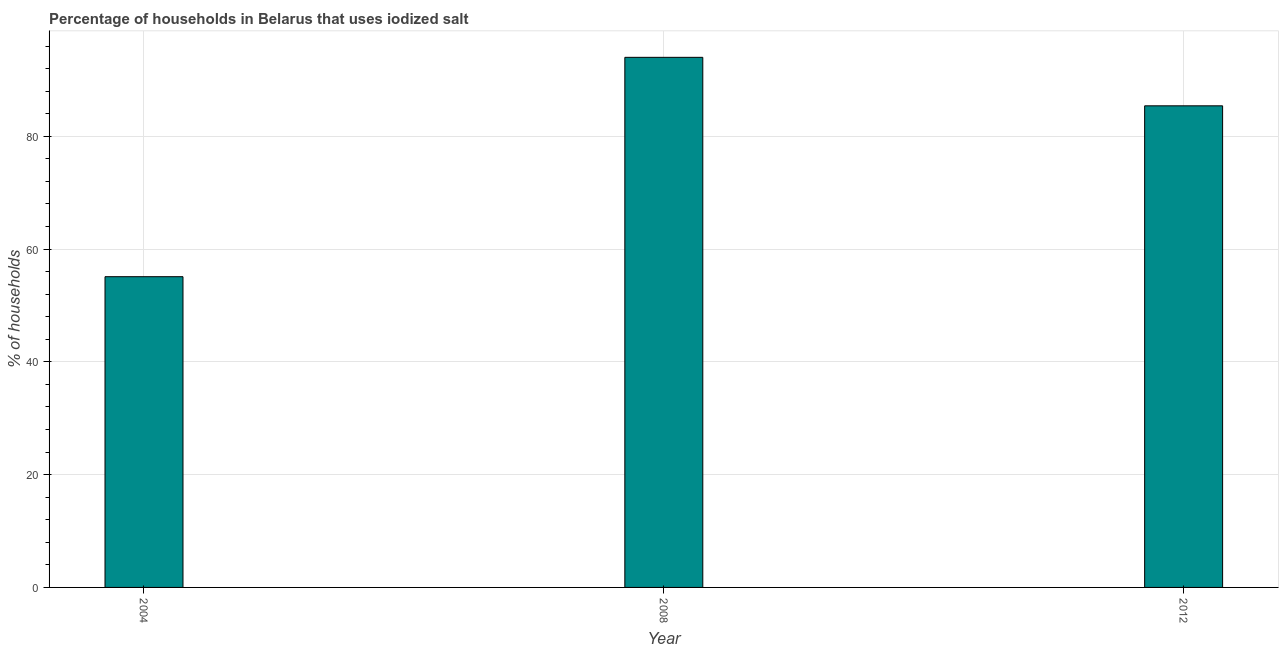Does the graph contain any zero values?
Keep it short and to the point. No. Does the graph contain grids?
Give a very brief answer. Yes. What is the title of the graph?
Your response must be concise. Percentage of households in Belarus that uses iodized salt. What is the label or title of the X-axis?
Your answer should be compact. Year. What is the label or title of the Y-axis?
Provide a succinct answer. % of households. What is the percentage of households where iodized salt is consumed in 2004?
Ensure brevity in your answer.  55.1. Across all years, what is the maximum percentage of households where iodized salt is consumed?
Your answer should be very brief. 94. Across all years, what is the minimum percentage of households where iodized salt is consumed?
Provide a short and direct response. 55.1. What is the sum of the percentage of households where iodized salt is consumed?
Offer a terse response. 234.5. What is the difference between the percentage of households where iodized salt is consumed in 2004 and 2012?
Your answer should be very brief. -30.3. What is the average percentage of households where iodized salt is consumed per year?
Provide a succinct answer. 78.17. What is the median percentage of households where iodized salt is consumed?
Your answer should be compact. 85.4. In how many years, is the percentage of households where iodized salt is consumed greater than 4 %?
Your answer should be compact. 3. Do a majority of the years between 2004 and 2012 (inclusive) have percentage of households where iodized salt is consumed greater than 36 %?
Provide a short and direct response. Yes. What is the ratio of the percentage of households where iodized salt is consumed in 2008 to that in 2012?
Provide a succinct answer. 1.1. What is the difference between the highest and the second highest percentage of households where iodized salt is consumed?
Ensure brevity in your answer.  8.6. Is the sum of the percentage of households where iodized salt is consumed in 2008 and 2012 greater than the maximum percentage of households where iodized salt is consumed across all years?
Make the answer very short. Yes. What is the difference between the highest and the lowest percentage of households where iodized salt is consumed?
Keep it short and to the point. 38.9. In how many years, is the percentage of households where iodized salt is consumed greater than the average percentage of households where iodized salt is consumed taken over all years?
Make the answer very short. 2. Are all the bars in the graph horizontal?
Give a very brief answer. No. What is the % of households in 2004?
Offer a terse response. 55.1. What is the % of households in 2008?
Your answer should be very brief. 94. What is the % of households in 2012?
Provide a short and direct response. 85.4. What is the difference between the % of households in 2004 and 2008?
Ensure brevity in your answer.  -38.9. What is the difference between the % of households in 2004 and 2012?
Your answer should be compact. -30.3. What is the difference between the % of households in 2008 and 2012?
Provide a short and direct response. 8.6. What is the ratio of the % of households in 2004 to that in 2008?
Ensure brevity in your answer.  0.59. What is the ratio of the % of households in 2004 to that in 2012?
Keep it short and to the point. 0.65. What is the ratio of the % of households in 2008 to that in 2012?
Your answer should be very brief. 1.1. 